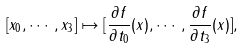<formula> <loc_0><loc_0><loc_500><loc_500>[ x _ { 0 } , \cdots , x _ { 3 } ] \mapsto [ \frac { \partial f } { \partial t _ { 0 } } ( x ) , \cdots , \frac { \partial f } { \partial t _ { 3 } } ( x ) ] ,</formula> 